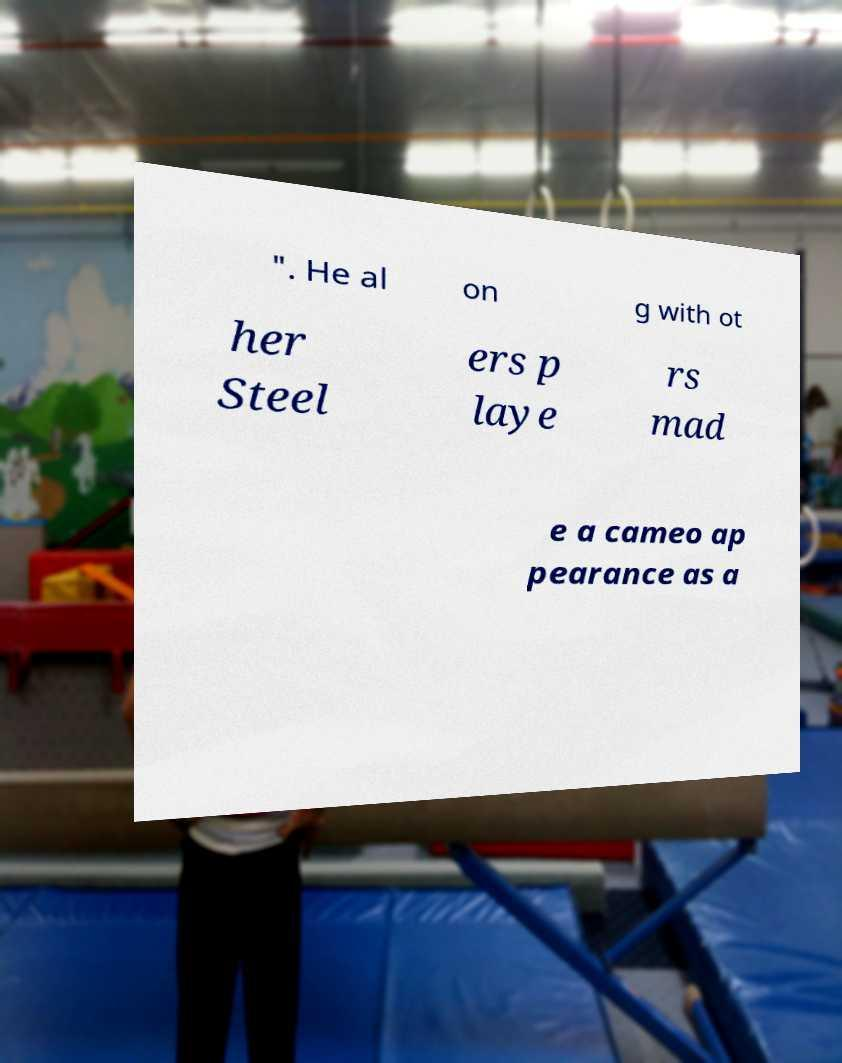Could you extract and type out the text from this image? ". He al on g with ot her Steel ers p laye rs mad e a cameo ap pearance as a 